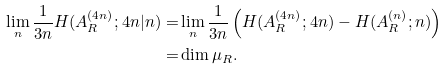<formula> <loc_0><loc_0><loc_500><loc_500>\lim _ { n } \frac { 1 } { 3 n } H ( A _ { R } ^ { ( 4 n ) } ; 4 n | n ) = & \lim _ { n } \frac { 1 } { 3 n } \left ( H ( A _ { R } ^ { ( 4 n ) } ; 4 n ) - H ( A _ { R } ^ { ( n ) } ; n ) \right ) \\ = & \dim \mu _ { R } .</formula> 